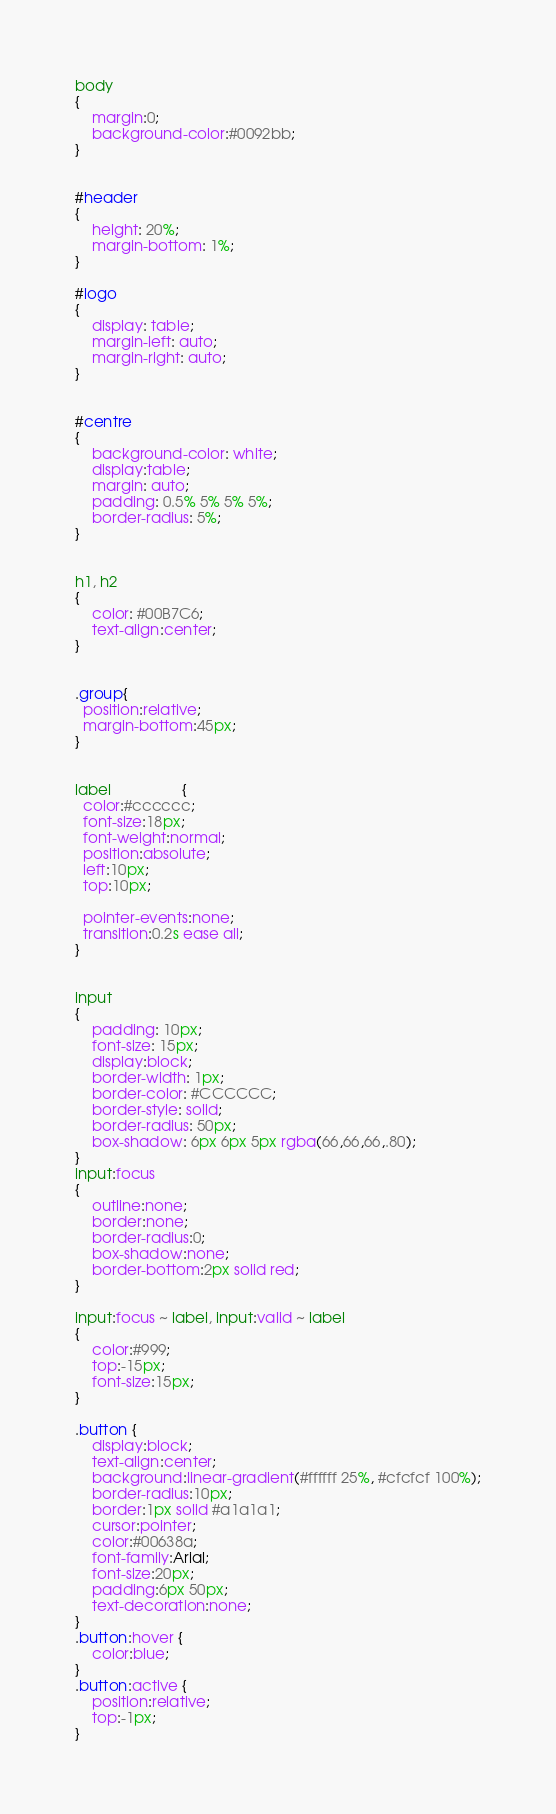Convert code to text. <code><loc_0><loc_0><loc_500><loc_500><_CSS_>body
{
	margin:0;
	background-color:#0092bb;
}


#header
{
	height: 20%;
	margin-bottom: 1%;
}

#logo
{
	display: table;
	margin-left: auto;
	margin-right: auto;
}


#centre
{
	background-color: white;
	display:table;
	margin: auto;
	padding: 0.5% 5% 5% 5%;
	border-radius: 5%;
}


h1, h2
{
	color: #00B7C6;
	text-align:center;
}


.group{
  position:relative;
  margin-bottom:45px;
}


label 				 {
  color:#cccccc;
  font-size:18px;
  font-weight:normal;
  position:absolute;
  left:10px;
  top:10px;

  pointer-events:none;
  transition:0.2s ease all;
}


input
{
	padding: 10px;
    font-size: 15px;
	display:block;
    border-width: 1px;
    border-color: #CCCCCC;
    border-style: solid;
    border-radius: 50px;
    box-shadow: 6px 6px 5px rgba(66,66,66,.80);
}
input:focus
{
	outline:none;
	border:none;
	border-radius:0;
	box-shadow:none;
	border-bottom:2px solid red;
}

input:focus ~ label, input:valid ~ label
{
	color:#999;
	top:-15px;
	font-size:15px;
}

.button {
	display:block;
	text-align:center;
	background:linear-gradient(#ffffff 25%, #cfcfcf 100%);
	border-radius:10px;
	border:1px solid #a1a1a1;
	cursor:pointer;
	color:#00638a;
	font-family:Arial;
	font-size:20px;
	padding:6px 50px;
	text-decoration:none;
}
.button:hover {
	color:blue;
}
.button:active {
	position:relative;
	top:-1px;
}

</code> 